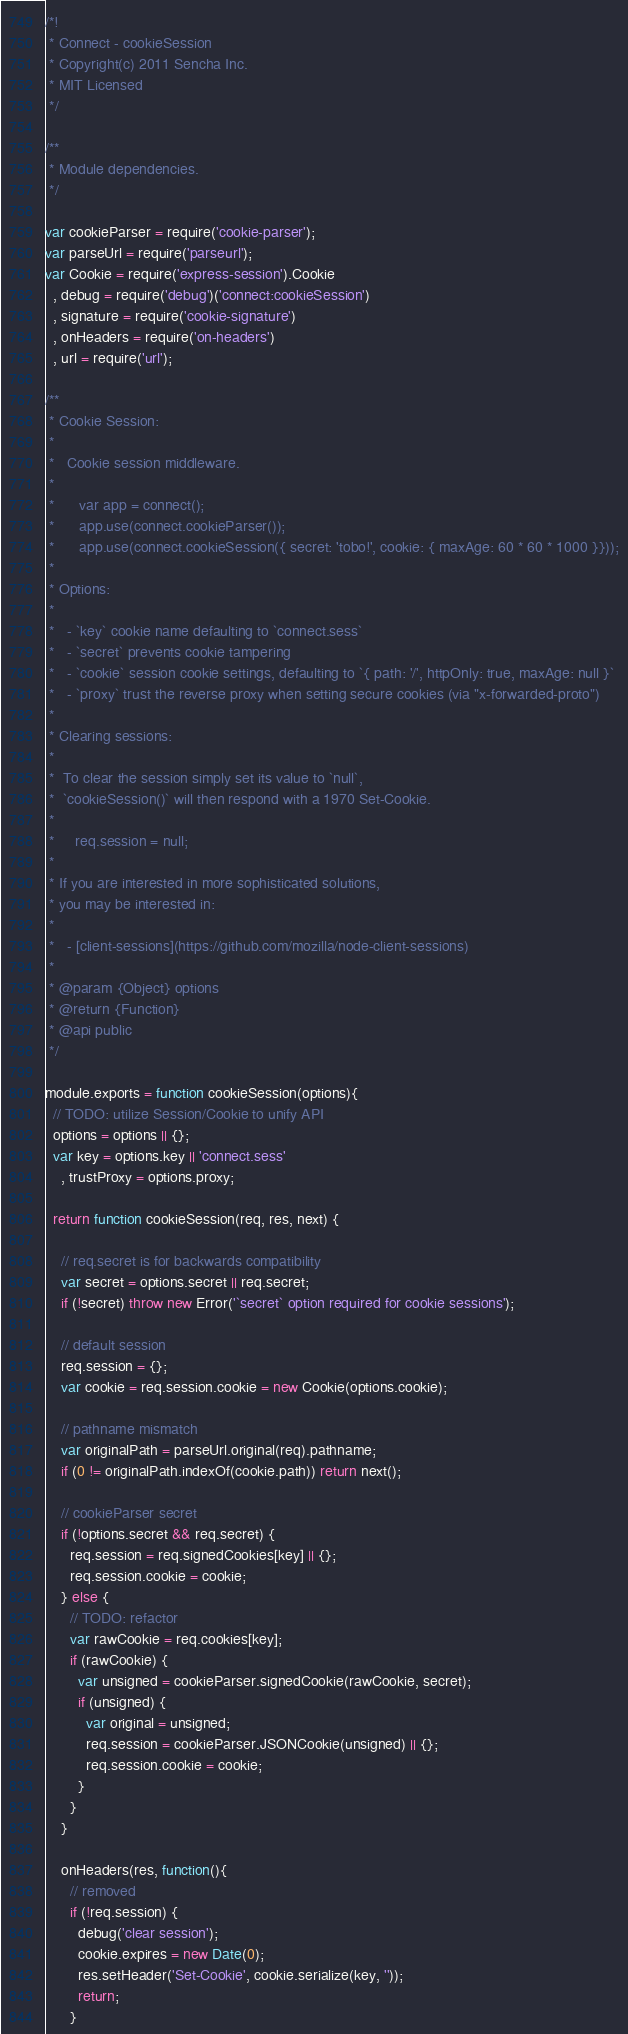Convert code to text. <code><loc_0><loc_0><loc_500><loc_500><_JavaScript_>/*!
 * Connect - cookieSession
 * Copyright(c) 2011 Sencha Inc.
 * MIT Licensed
 */

/**
 * Module dependencies.
 */

var cookieParser = require('cookie-parser');
var parseUrl = require('parseurl');
var Cookie = require('express-session').Cookie
  , debug = require('debug')('connect:cookieSession')
  , signature = require('cookie-signature')
  , onHeaders = require('on-headers')
  , url = require('url');

/**
 * Cookie Session:
 *
 *   Cookie session middleware.
 *
 *      var app = connect();
 *      app.use(connect.cookieParser());
 *      app.use(connect.cookieSession({ secret: 'tobo!', cookie: { maxAge: 60 * 60 * 1000 }}));
 *
 * Options:
 *
 *   - `key` cookie name defaulting to `connect.sess`
 *   - `secret` prevents cookie tampering
 *   - `cookie` session cookie settings, defaulting to `{ path: '/', httpOnly: true, maxAge: null }`
 *   - `proxy` trust the reverse proxy when setting secure cookies (via "x-forwarded-proto")
 *
 * Clearing sessions:
 *
 *  To clear the session simply set its value to `null`,
 *  `cookieSession()` will then respond with a 1970 Set-Cookie.
 *
 *     req.session = null;
 *
 * If you are interested in more sophisticated solutions,
 * you may be interested in:
 *
 *   - [client-sessions](https://github.com/mozilla/node-client-sessions)
 *
 * @param {Object} options
 * @return {Function}
 * @api public
 */

module.exports = function cookieSession(options){
  // TODO: utilize Session/Cookie to unify API
  options = options || {};
  var key = options.key || 'connect.sess'
    , trustProxy = options.proxy;

  return function cookieSession(req, res, next) {

    // req.secret is for backwards compatibility
    var secret = options.secret || req.secret;
    if (!secret) throw new Error('`secret` option required for cookie sessions');

    // default session
    req.session = {};
    var cookie = req.session.cookie = new Cookie(options.cookie);

    // pathname mismatch
    var originalPath = parseUrl.original(req).pathname;
    if (0 != originalPath.indexOf(cookie.path)) return next();

    // cookieParser secret
    if (!options.secret && req.secret) {
      req.session = req.signedCookies[key] || {};
      req.session.cookie = cookie;
    } else {
      // TODO: refactor
      var rawCookie = req.cookies[key];
      if (rawCookie) {
        var unsigned = cookieParser.signedCookie(rawCookie, secret);
        if (unsigned) {
          var original = unsigned;
          req.session = cookieParser.JSONCookie(unsigned) || {};
          req.session.cookie = cookie;
        }
      }
    }

    onHeaders(res, function(){
      // removed
      if (!req.session) {
        debug('clear session');
        cookie.expires = new Date(0);
        res.setHeader('Set-Cookie', cookie.serialize(key, ''));
        return;
      }
</code> 